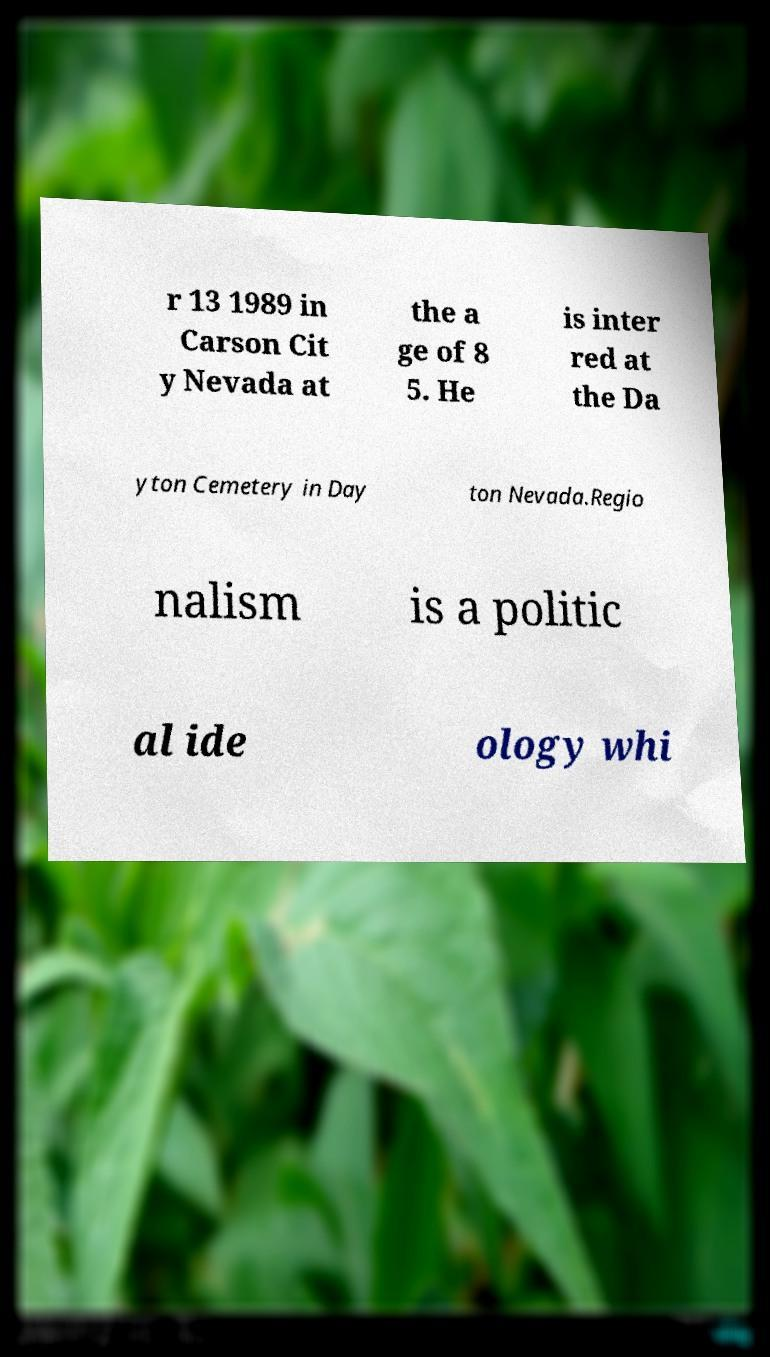Can you accurately transcribe the text from the provided image for me? r 13 1989 in Carson Cit y Nevada at the a ge of 8 5. He is inter red at the Da yton Cemetery in Day ton Nevada.Regio nalism is a politic al ide ology whi 